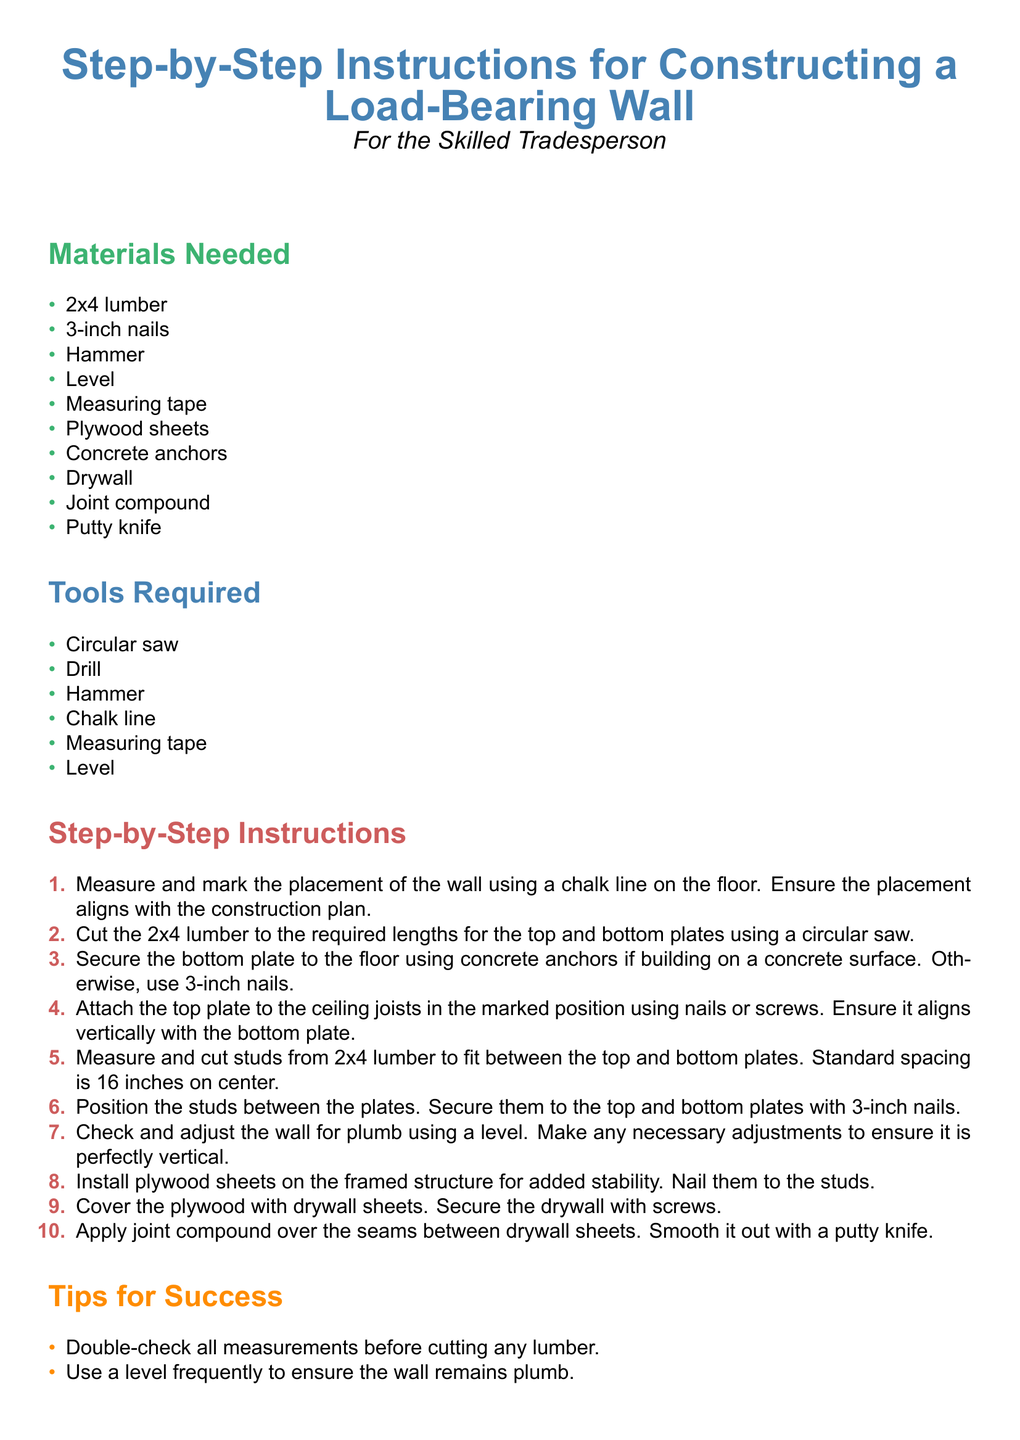What materials are needed for the wall construction? The materials section lists all items required for the wall construction.
Answer: 2x4 lumber, 3-inch nails, Hammer, Level, Measuring tape, Plywood sheets, Concrete anchors, Drywall, Joint compound, Putty knife How many steps are included in the instructions? The number of steps can be counted from the step-by-step instructions section.
Answer: 10 What is the standard spacing for the studs? The step about cutting studs specifies the standard spacing between them.
Answer: 16 inches on center What tool is required to check if the wall is vertical? The instructions mention a specific tool for ensuring verticality in the wall.
Answer: Level What is the first step in constructing the wall? The first step of the wall construction process is explicitly stated in the document.
Answer: Measure and mark the placement of the wall using a chalk line on the floor What should be done with the seams between drywall sheets? The instructions detail what to do with drywall seams in one of the last steps.
Answer: Apply joint compound over the seams between drywall sheets Why is it important to consult the engineer? The tips section emphasizes a key reason for consulting the engineer during construction.
Answer: For any clarifications on the construction plan What should be done before cutting any lumber? One of the tips stresses an important precaution before making cuts.
Answer: Double-check all measurements 